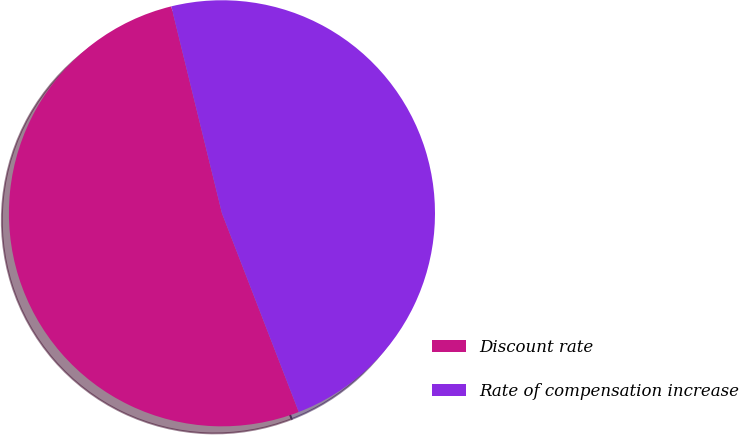Convert chart to OTSL. <chart><loc_0><loc_0><loc_500><loc_500><pie_chart><fcel>Discount rate<fcel>Rate of compensation increase<nl><fcel>52.05%<fcel>47.95%<nl></chart> 